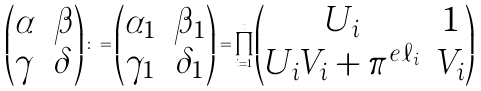<formula> <loc_0><loc_0><loc_500><loc_500>\begin{pmatrix} \alpha & \beta \\ \gamma & \delta \end{pmatrix} \colon = \begin{pmatrix} \alpha _ { 1 } & \beta _ { 1 } \\ \gamma _ { 1 } & \delta _ { 1 } \end{pmatrix} = \prod _ { i = 1 } ^ { t } \begin{pmatrix} U _ { i } & 1 \\ U _ { i } V _ { i } + \pi ^ { e \ell _ { i } } & V _ { i } \end{pmatrix}</formula> 